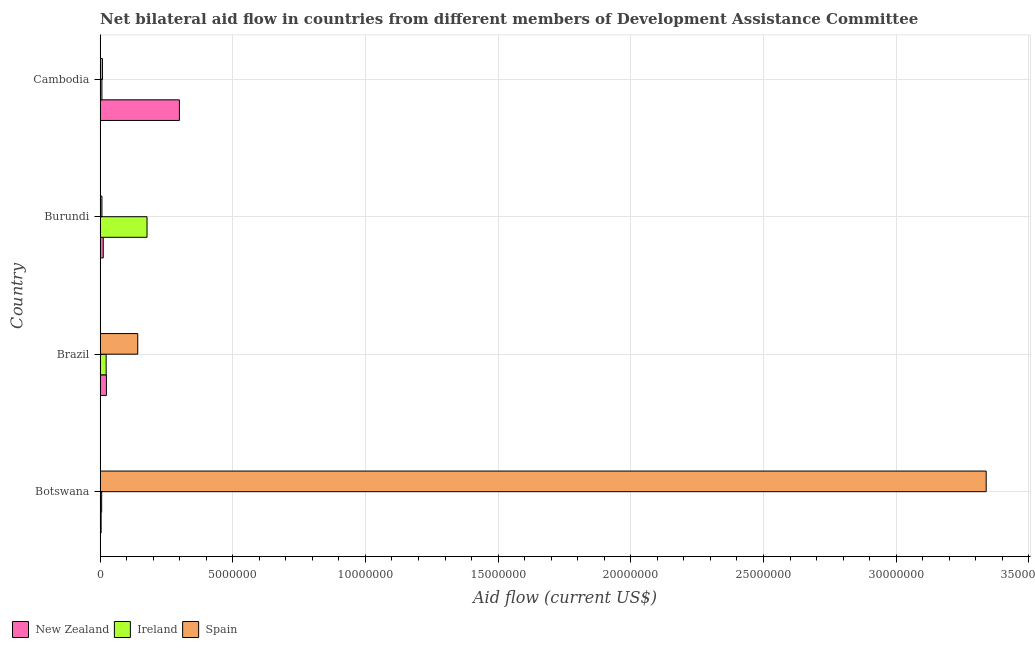How many different coloured bars are there?
Your answer should be very brief. 3. How many bars are there on the 2nd tick from the top?
Your answer should be very brief. 3. How many bars are there on the 2nd tick from the bottom?
Keep it short and to the point. 3. What is the label of the 4th group of bars from the top?
Ensure brevity in your answer.  Botswana. In how many cases, is the number of bars for a given country not equal to the number of legend labels?
Ensure brevity in your answer.  0. What is the amount of aid provided by spain in Brazil?
Give a very brief answer. 1.42e+06. Across all countries, what is the maximum amount of aid provided by spain?
Your answer should be very brief. 3.34e+07. Across all countries, what is the minimum amount of aid provided by spain?
Ensure brevity in your answer.  7.00e+04. In which country was the amount of aid provided by ireland maximum?
Ensure brevity in your answer.  Burundi. In which country was the amount of aid provided by new zealand minimum?
Make the answer very short. Botswana. What is the total amount of aid provided by ireland in the graph?
Ensure brevity in your answer.  2.13e+06. What is the difference between the amount of aid provided by new zealand in Botswana and that in Cambodia?
Offer a very short reply. -2.95e+06. What is the difference between the amount of aid provided by new zealand in Brazil and the amount of aid provided by ireland in Cambodia?
Give a very brief answer. 1.70e+05. What is the average amount of aid provided by spain per country?
Keep it short and to the point. 8.74e+06. What is the difference between the amount of aid provided by ireland and amount of aid provided by spain in Cambodia?
Offer a terse response. -2.00e+04. In how many countries, is the amount of aid provided by ireland greater than 14000000 US$?
Ensure brevity in your answer.  0. What is the ratio of the amount of aid provided by spain in Botswana to that in Cambodia?
Your answer should be compact. 371. Is the amount of aid provided by new zealand in Botswana less than that in Cambodia?
Your response must be concise. Yes. What is the difference between the highest and the second highest amount of aid provided by spain?
Your answer should be very brief. 3.20e+07. What is the difference between the highest and the lowest amount of aid provided by new zealand?
Keep it short and to the point. 2.95e+06. In how many countries, is the amount of aid provided by ireland greater than the average amount of aid provided by ireland taken over all countries?
Offer a very short reply. 1. What does the 2nd bar from the top in Burundi represents?
Keep it short and to the point. Ireland. Is it the case that in every country, the sum of the amount of aid provided by new zealand and amount of aid provided by ireland is greater than the amount of aid provided by spain?
Keep it short and to the point. No. How many bars are there?
Provide a short and direct response. 12. Are the values on the major ticks of X-axis written in scientific E-notation?
Offer a very short reply. No. Does the graph contain any zero values?
Offer a very short reply. No. Does the graph contain grids?
Your response must be concise. Yes. Where does the legend appear in the graph?
Your answer should be compact. Bottom left. How many legend labels are there?
Keep it short and to the point. 3. What is the title of the graph?
Offer a terse response. Net bilateral aid flow in countries from different members of Development Assistance Committee. What is the label or title of the X-axis?
Your response must be concise. Aid flow (current US$). What is the Aid flow (current US$) in New Zealand in Botswana?
Your response must be concise. 4.00e+04. What is the Aid flow (current US$) of Ireland in Botswana?
Offer a very short reply. 6.00e+04. What is the Aid flow (current US$) in Spain in Botswana?
Keep it short and to the point. 3.34e+07. What is the Aid flow (current US$) in New Zealand in Brazil?
Your response must be concise. 2.40e+05. What is the Aid flow (current US$) of Ireland in Brazil?
Keep it short and to the point. 2.30e+05. What is the Aid flow (current US$) of Spain in Brazil?
Offer a terse response. 1.42e+06. What is the Aid flow (current US$) in New Zealand in Burundi?
Your response must be concise. 1.20e+05. What is the Aid flow (current US$) of Ireland in Burundi?
Make the answer very short. 1.77e+06. What is the Aid flow (current US$) in Spain in Burundi?
Your answer should be compact. 7.00e+04. What is the Aid flow (current US$) in New Zealand in Cambodia?
Your response must be concise. 2.99e+06. What is the Aid flow (current US$) in Ireland in Cambodia?
Your response must be concise. 7.00e+04. Across all countries, what is the maximum Aid flow (current US$) of New Zealand?
Keep it short and to the point. 2.99e+06. Across all countries, what is the maximum Aid flow (current US$) of Ireland?
Offer a very short reply. 1.77e+06. Across all countries, what is the maximum Aid flow (current US$) of Spain?
Your answer should be compact. 3.34e+07. Across all countries, what is the minimum Aid flow (current US$) of New Zealand?
Offer a very short reply. 4.00e+04. Across all countries, what is the minimum Aid flow (current US$) of Spain?
Provide a short and direct response. 7.00e+04. What is the total Aid flow (current US$) in New Zealand in the graph?
Offer a terse response. 3.39e+06. What is the total Aid flow (current US$) in Ireland in the graph?
Offer a very short reply. 2.13e+06. What is the total Aid flow (current US$) in Spain in the graph?
Offer a very short reply. 3.50e+07. What is the difference between the Aid flow (current US$) in Spain in Botswana and that in Brazil?
Make the answer very short. 3.20e+07. What is the difference between the Aid flow (current US$) of New Zealand in Botswana and that in Burundi?
Provide a succinct answer. -8.00e+04. What is the difference between the Aid flow (current US$) in Ireland in Botswana and that in Burundi?
Your response must be concise. -1.71e+06. What is the difference between the Aid flow (current US$) in Spain in Botswana and that in Burundi?
Your answer should be very brief. 3.33e+07. What is the difference between the Aid flow (current US$) of New Zealand in Botswana and that in Cambodia?
Provide a short and direct response. -2.95e+06. What is the difference between the Aid flow (current US$) of Ireland in Botswana and that in Cambodia?
Offer a terse response. -10000. What is the difference between the Aid flow (current US$) in Spain in Botswana and that in Cambodia?
Offer a very short reply. 3.33e+07. What is the difference between the Aid flow (current US$) of Ireland in Brazil and that in Burundi?
Your answer should be compact. -1.54e+06. What is the difference between the Aid flow (current US$) in Spain in Brazil and that in Burundi?
Your answer should be very brief. 1.35e+06. What is the difference between the Aid flow (current US$) in New Zealand in Brazil and that in Cambodia?
Give a very brief answer. -2.75e+06. What is the difference between the Aid flow (current US$) in Spain in Brazil and that in Cambodia?
Provide a succinct answer. 1.33e+06. What is the difference between the Aid flow (current US$) in New Zealand in Burundi and that in Cambodia?
Offer a terse response. -2.87e+06. What is the difference between the Aid flow (current US$) in Ireland in Burundi and that in Cambodia?
Your answer should be compact. 1.70e+06. What is the difference between the Aid flow (current US$) in New Zealand in Botswana and the Aid flow (current US$) in Spain in Brazil?
Make the answer very short. -1.38e+06. What is the difference between the Aid flow (current US$) in Ireland in Botswana and the Aid flow (current US$) in Spain in Brazil?
Offer a very short reply. -1.36e+06. What is the difference between the Aid flow (current US$) of New Zealand in Botswana and the Aid flow (current US$) of Ireland in Burundi?
Make the answer very short. -1.73e+06. What is the difference between the Aid flow (current US$) in New Zealand in Botswana and the Aid flow (current US$) in Spain in Burundi?
Give a very brief answer. -3.00e+04. What is the difference between the Aid flow (current US$) in New Zealand in Botswana and the Aid flow (current US$) in Ireland in Cambodia?
Provide a succinct answer. -3.00e+04. What is the difference between the Aid flow (current US$) in Ireland in Botswana and the Aid flow (current US$) in Spain in Cambodia?
Your answer should be compact. -3.00e+04. What is the difference between the Aid flow (current US$) of New Zealand in Brazil and the Aid flow (current US$) of Ireland in Burundi?
Your response must be concise. -1.53e+06. What is the difference between the Aid flow (current US$) of New Zealand in Brazil and the Aid flow (current US$) of Spain in Burundi?
Provide a short and direct response. 1.70e+05. What is the difference between the Aid flow (current US$) in Ireland in Brazil and the Aid flow (current US$) in Spain in Burundi?
Keep it short and to the point. 1.60e+05. What is the difference between the Aid flow (current US$) in New Zealand in Brazil and the Aid flow (current US$) in Spain in Cambodia?
Make the answer very short. 1.50e+05. What is the difference between the Aid flow (current US$) in New Zealand in Burundi and the Aid flow (current US$) in Ireland in Cambodia?
Keep it short and to the point. 5.00e+04. What is the difference between the Aid flow (current US$) of New Zealand in Burundi and the Aid flow (current US$) of Spain in Cambodia?
Keep it short and to the point. 3.00e+04. What is the difference between the Aid flow (current US$) in Ireland in Burundi and the Aid flow (current US$) in Spain in Cambodia?
Keep it short and to the point. 1.68e+06. What is the average Aid flow (current US$) in New Zealand per country?
Your answer should be compact. 8.48e+05. What is the average Aid flow (current US$) in Ireland per country?
Give a very brief answer. 5.32e+05. What is the average Aid flow (current US$) in Spain per country?
Offer a terse response. 8.74e+06. What is the difference between the Aid flow (current US$) in New Zealand and Aid flow (current US$) in Ireland in Botswana?
Your answer should be very brief. -2.00e+04. What is the difference between the Aid flow (current US$) in New Zealand and Aid flow (current US$) in Spain in Botswana?
Give a very brief answer. -3.34e+07. What is the difference between the Aid flow (current US$) of Ireland and Aid flow (current US$) of Spain in Botswana?
Your answer should be compact. -3.33e+07. What is the difference between the Aid flow (current US$) of New Zealand and Aid flow (current US$) of Spain in Brazil?
Give a very brief answer. -1.18e+06. What is the difference between the Aid flow (current US$) of Ireland and Aid flow (current US$) of Spain in Brazil?
Provide a short and direct response. -1.19e+06. What is the difference between the Aid flow (current US$) of New Zealand and Aid flow (current US$) of Ireland in Burundi?
Offer a very short reply. -1.65e+06. What is the difference between the Aid flow (current US$) of Ireland and Aid flow (current US$) of Spain in Burundi?
Your answer should be very brief. 1.70e+06. What is the difference between the Aid flow (current US$) in New Zealand and Aid flow (current US$) in Ireland in Cambodia?
Provide a succinct answer. 2.92e+06. What is the difference between the Aid flow (current US$) in New Zealand and Aid flow (current US$) in Spain in Cambodia?
Give a very brief answer. 2.90e+06. What is the difference between the Aid flow (current US$) of Ireland and Aid flow (current US$) of Spain in Cambodia?
Give a very brief answer. -2.00e+04. What is the ratio of the Aid flow (current US$) in New Zealand in Botswana to that in Brazil?
Give a very brief answer. 0.17. What is the ratio of the Aid flow (current US$) in Ireland in Botswana to that in Brazil?
Provide a short and direct response. 0.26. What is the ratio of the Aid flow (current US$) of Spain in Botswana to that in Brazil?
Offer a very short reply. 23.51. What is the ratio of the Aid flow (current US$) of New Zealand in Botswana to that in Burundi?
Ensure brevity in your answer.  0.33. What is the ratio of the Aid flow (current US$) in Ireland in Botswana to that in Burundi?
Your response must be concise. 0.03. What is the ratio of the Aid flow (current US$) in Spain in Botswana to that in Burundi?
Provide a succinct answer. 477. What is the ratio of the Aid flow (current US$) in New Zealand in Botswana to that in Cambodia?
Make the answer very short. 0.01. What is the ratio of the Aid flow (current US$) in Spain in Botswana to that in Cambodia?
Your answer should be very brief. 371. What is the ratio of the Aid flow (current US$) of New Zealand in Brazil to that in Burundi?
Ensure brevity in your answer.  2. What is the ratio of the Aid flow (current US$) of Ireland in Brazil to that in Burundi?
Keep it short and to the point. 0.13. What is the ratio of the Aid flow (current US$) of Spain in Brazil to that in Burundi?
Offer a very short reply. 20.29. What is the ratio of the Aid flow (current US$) in New Zealand in Brazil to that in Cambodia?
Give a very brief answer. 0.08. What is the ratio of the Aid flow (current US$) in Ireland in Brazil to that in Cambodia?
Your response must be concise. 3.29. What is the ratio of the Aid flow (current US$) in Spain in Brazil to that in Cambodia?
Keep it short and to the point. 15.78. What is the ratio of the Aid flow (current US$) in New Zealand in Burundi to that in Cambodia?
Give a very brief answer. 0.04. What is the ratio of the Aid flow (current US$) in Ireland in Burundi to that in Cambodia?
Your answer should be very brief. 25.29. What is the difference between the highest and the second highest Aid flow (current US$) of New Zealand?
Offer a terse response. 2.75e+06. What is the difference between the highest and the second highest Aid flow (current US$) of Ireland?
Provide a succinct answer. 1.54e+06. What is the difference between the highest and the second highest Aid flow (current US$) in Spain?
Make the answer very short. 3.20e+07. What is the difference between the highest and the lowest Aid flow (current US$) of New Zealand?
Offer a terse response. 2.95e+06. What is the difference between the highest and the lowest Aid flow (current US$) of Ireland?
Provide a short and direct response. 1.71e+06. What is the difference between the highest and the lowest Aid flow (current US$) in Spain?
Ensure brevity in your answer.  3.33e+07. 